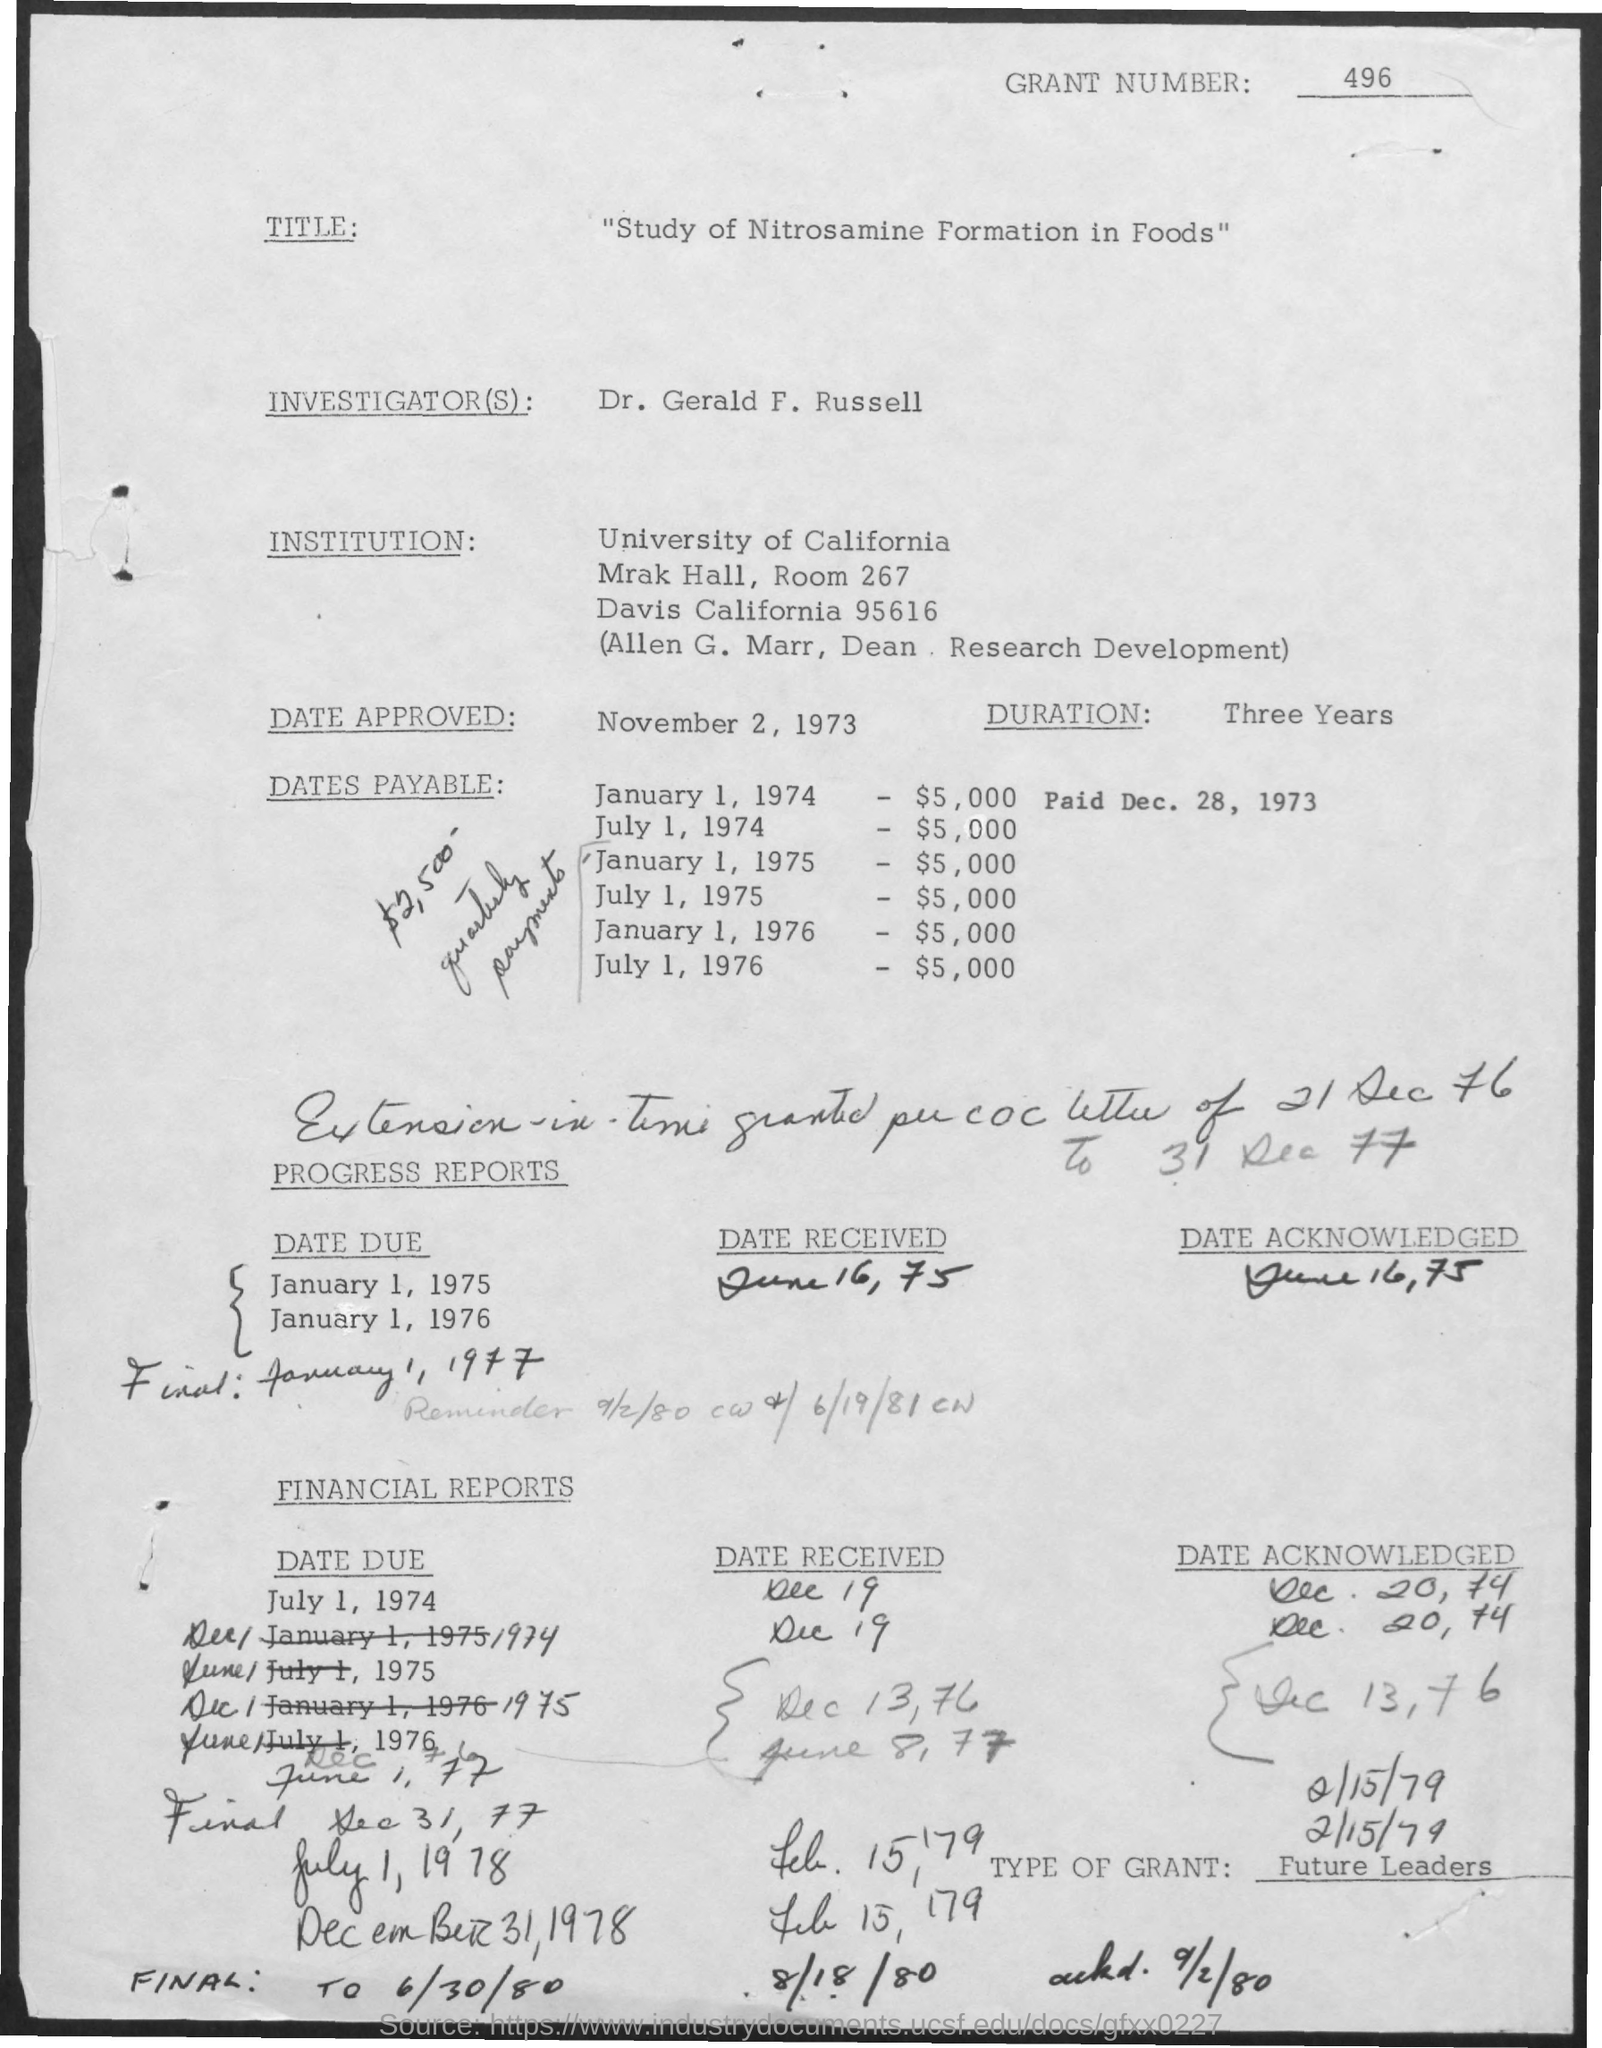Identify some key points in this picture. The approved date mentioned in the document is November 2, 1973. The investigator mentioned in the document is Dr. Gerald F. Russell. The document mentions the University of California. The given document is a study on the formation of Nitrosamine in foods. The grant number mentioned in the given document is 496. 